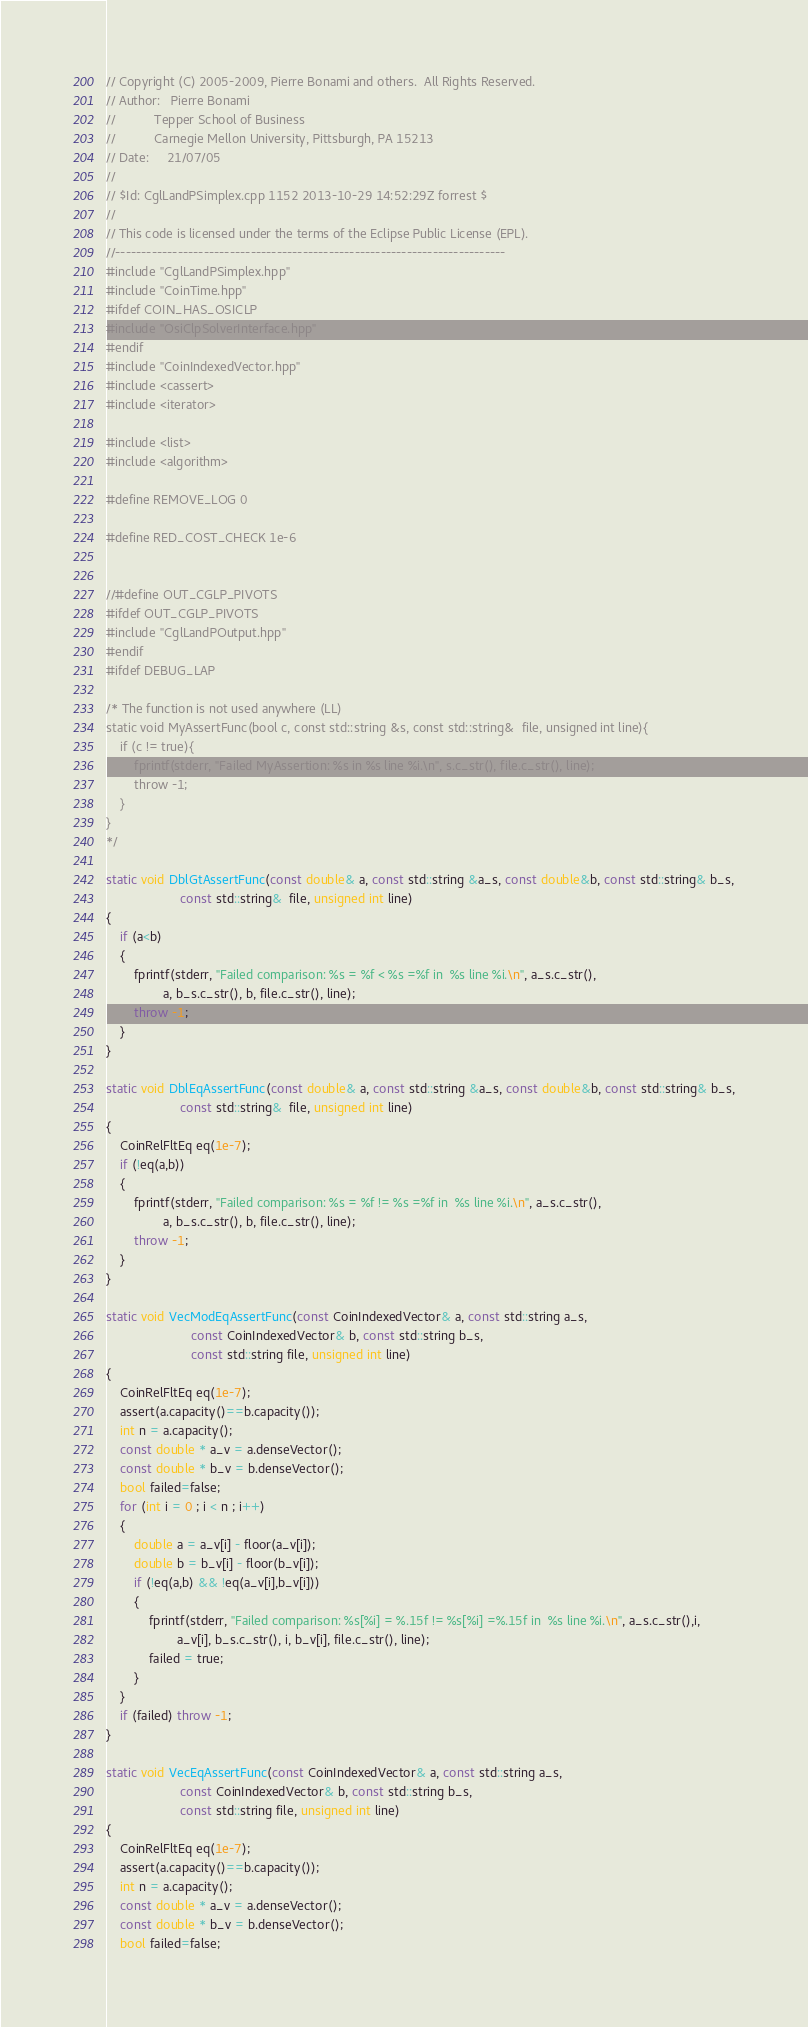<code> <loc_0><loc_0><loc_500><loc_500><_C++_>// Copyright (C) 2005-2009, Pierre Bonami and others.  All Rights Reserved.
// Author:   Pierre Bonami
//           Tepper School of Business
//           Carnegie Mellon University, Pittsburgh, PA 15213
// Date:     21/07/05
//
// $Id: CglLandPSimplex.cpp 1152 2013-10-29 14:52:29Z forrest $
//
// This code is licensed under the terms of the Eclipse Public License (EPL).
//---------------------------------------------------------------------------
#include "CglLandPSimplex.hpp"
#include "CoinTime.hpp"
#ifdef COIN_HAS_OSICLP
#include "OsiClpSolverInterface.hpp"
#endif
#include "CoinIndexedVector.hpp"
#include <cassert>
#include <iterator>

#include <list>
#include <algorithm>

#define REMOVE_LOG 0

#define RED_COST_CHECK 1e-6


//#define OUT_CGLP_PIVOTS
#ifdef OUT_CGLP_PIVOTS
#include "CglLandPOutput.hpp"
#endif
#ifdef DEBUG_LAP

/* The function is not used anywhere (LL)
static void MyAssertFunc(bool c, const std::string &s, const std::string&  file, unsigned int line){
    if (c != true){
        fprintf(stderr, "Failed MyAssertion: %s in %s line %i.\n", s.c_str(), file.c_str(), line);
        throw -1;
    }
}
*/

static void DblGtAssertFunc(const double& a, const std::string &a_s, const double&b, const std::string& b_s,
                     const std::string&  file, unsigned int line)
{
    if (a<b)
    {
        fprintf(stderr, "Failed comparison: %s = %f < %s =%f in  %s line %i.\n", a_s.c_str(),
                a, b_s.c_str(), b, file.c_str(), line);
        throw -1;
    }
}

static void DblEqAssertFunc(const double& a, const std::string &a_s, const double&b, const std::string& b_s,
                     const std::string&  file, unsigned int line)
{
    CoinRelFltEq eq(1e-7);
    if (!eq(a,b))
    {
        fprintf(stderr, "Failed comparison: %s = %f != %s =%f in  %s line %i.\n", a_s.c_str(),
                a, b_s.c_str(), b, file.c_str(), line);
        throw -1;
    }
}

static void VecModEqAssertFunc(const CoinIndexedVector& a, const std::string a_s,
                        const CoinIndexedVector& b, const std::string b_s,
                        const std::string file, unsigned int line)
{
    CoinRelFltEq eq(1e-7);
    assert(a.capacity()==b.capacity());
    int n = a.capacity();
    const double * a_v = a.denseVector();
    const double * b_v = b.denseVector();
    bool failed=false;
    for (int i = 0 ; i < n ; i++)
    {
        double a = a_v[i] - floor(a_v[i]);
        double b = b_v[i] - floor(b_v[i]);
        if (!eq(a,b) && !eq(a_v[i],b_v[i]))
        {
            fprintf(stderr, "Failed comparison: %s[%i] = %.15f != %s[%i] =%.15f in  %s line %i.\n", a_s.c_str(),i,
                    a_v[i], b_s.c_str(), i, b_v[i], file.c_str(), line);
            failed = true;
        }
    }
    if (failed) throw -1;
}

static void VecEqAssertFunc(const CoinIndexedVector& a, const std::string a_s,
                     const CoinIndexedVector& b, const std::string b_s,
                     const std::string file, unsigned int line)
{
    CoinRelFltEq eq(1e-7);
    assert(a.capacity()==b.capacity());
    int n = a.capacity();
    const double * a_v = a.denseVector();
    const double * b_v = b.denseVector();
    bool failed=false;</code> 